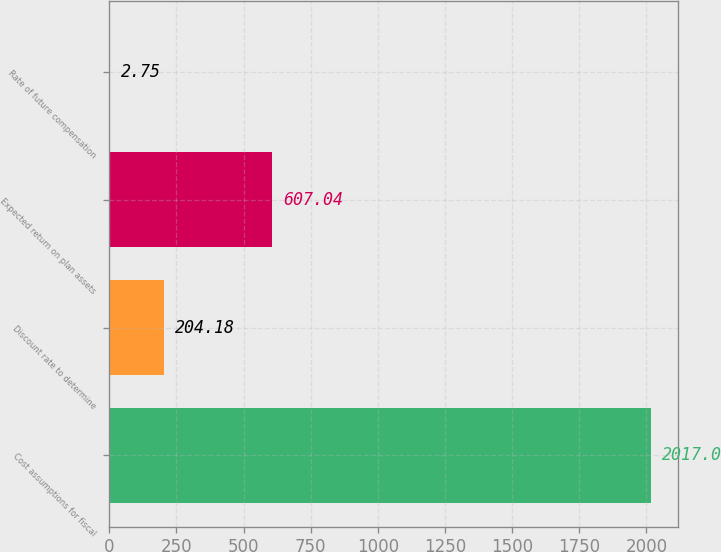Convert chart. <chart><loc_0><loc_0><loc_500><loc_500><bar_chart><fcel>Cost assumptions for fiscal<fcel>Discount rate to determine<fcel>Expected return on plan assets<fcel>Rate of future compensation<nl><fcel>2017<fcel>204.18<fcel>607.04<fcel>2.75<nl></chart> 